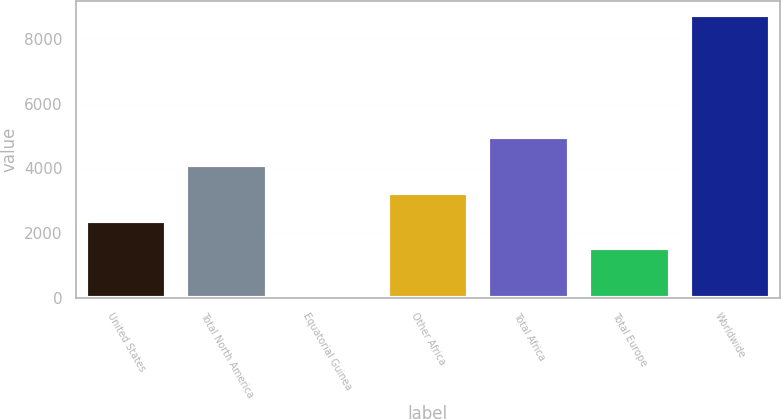<chart> <loc_0><loc_0><loc_500><loc_500><bar_chart><fcel>United States<fcel>Total North America<fcel>Equatorial Guinea<fcel>Other Africa<fcel>Total Africa<fcel>Total Europe<fcel>Worldwide<nl><fcel>2380<fcel>4106<fcel>98<fcel>3243<fcel>4969<fcel>1517<fcel>8728<nl></chart> 